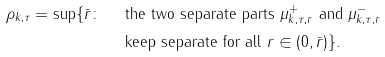<formula> <loc_0><loc_0><loc_500><loc_500>\rho _ { k , \tau } = \sup \{ \bar { r } \colon \ \ & \text {the two separate parts $\mu^{+}_{k,\tau,r}$ and $\mu^{-}_{k,\tau,r}$} \\ & \text {keep separate for all} \ r \in ( 0 , \bar { r } ) \} .</formula> 